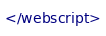<code> <loc_0><loc_0><loc_500><loc_500><_XML_></webscript>
</code> 